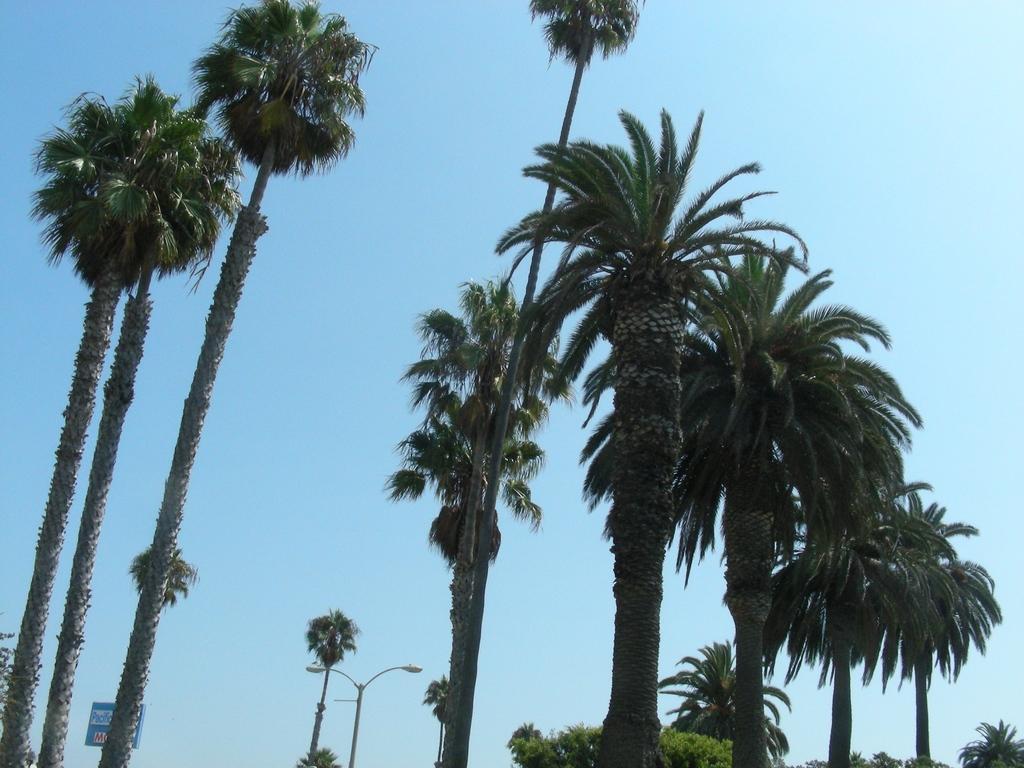Could you give a brief overview of what you see in this image? In this image there are trees, pole, in the background there is blue sky. 